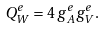<formula> <loc_0><loc_0><loc_500><loc_500>Q _ { W } ^ { e } = 4 \, g _ { A } ^ { e } g _ { V } ^ { e } .</formula> 